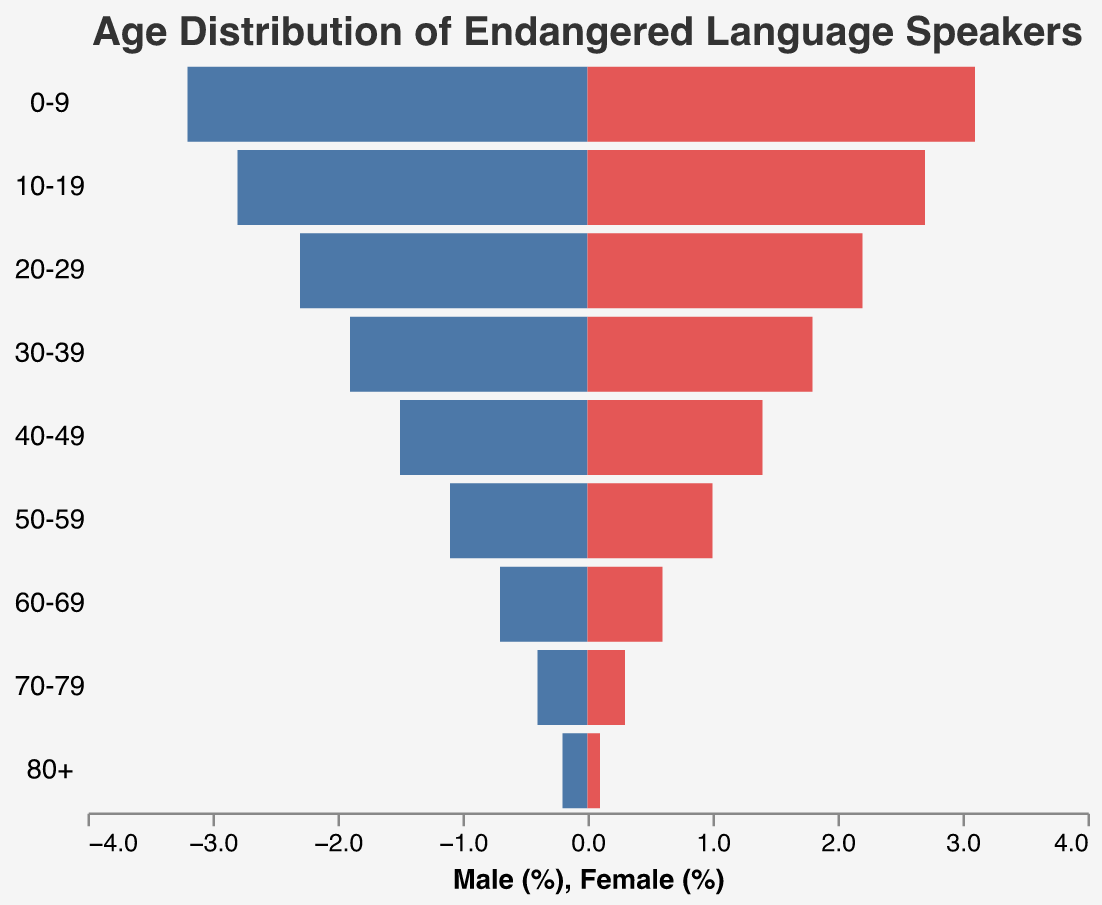What is the title of the chart? Look at the top of the chart to find the title.
Answer: "Age Distribution of Endangered Language Speakers" How many age groups are represented in the chart? Count the distinct age group categories in the y-axis labels.
Answer: 9 What color represents the male population in the chart? Observe the color of the bars on the left side of the chart.
Answer: Blue Which age group has the highest percentage of male speakers? Identify the age group with the largest negative value (since male values are negative) on the x-axis.
Answer: 0-9 Which age group has the lowest percentage of female speakers? Identify the age group with the smallest positive value on the x-axis for the female bars.
Answer: 80+ What is the percentage of female speakers in the age group 30-39? Locate the 30-39 age group and read the corresponding female bar value.
Answer: 1.8% What is the total percentage of male and female speakers combined in the age group 50-59? Add the percentages of male and female speakers in the 50-59 age group (1.1% male + 1.0% female).
Answer: 2.1% How does the percentage of male speakers in the age group 60-69 compare to the female speakers in the same group? Compare the negative value (male) and the positive value (female) for the 60-69 age group.
Answer: 0.7% male, 0.6% female; male percentage is slightly higher Is there a noticeable trend in the percentages of male and female speakers as age increases? Observe the bar lengths from the youngest to oldest age groups to see if they increase or decrease.
Answer: Both male and female percentages decrease with age For which age group is the gap between male and female speaker percentages the smallest? Subtract the female percentage from the male percentage for each age group and identify the smallest difference.
Answer: 10-19 (0.1% difference) 